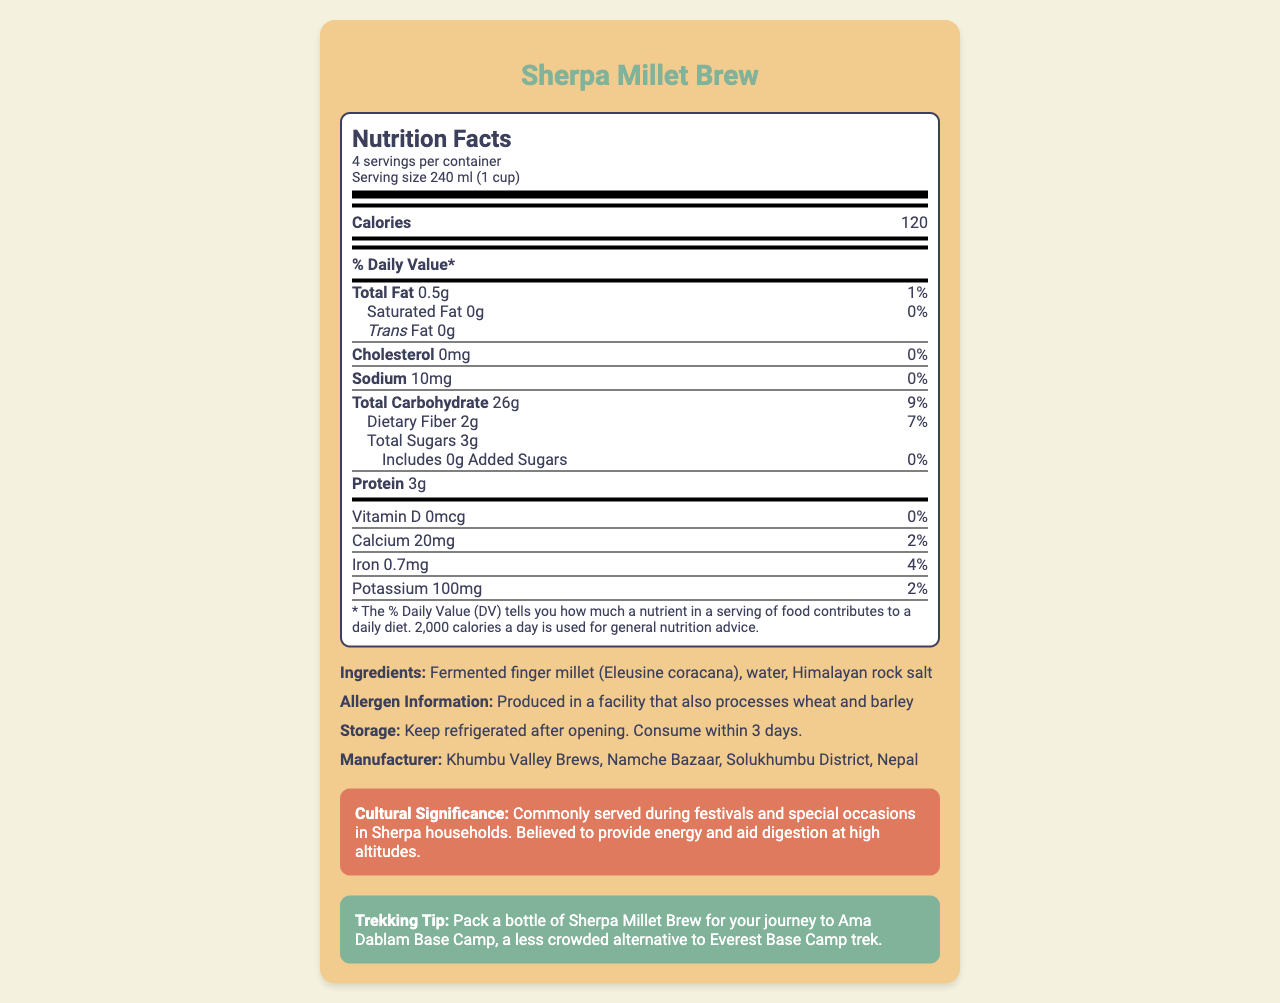what is the serving size of Sherpa Millet Brew? The serving size is explicitly mentioned in the document as "240 ml (1 cup)".
Answer: 240 ml (1 cup) how many calories are in one serving of Sherpa Millet Brew? The document states that there are 120 calories per serving.
Answer: 120 how much sodium does one serving of Sherpa Millet Brew contain? The Nutrition Facts section lists sodium content as 10 mg per serving.
Answer: 10 mg what is the daily value percentage of total fat in one serving? The document specifies that the daily value percentage for total fat in one serving is 1%.
Answer: 1% how many grams of protein are in one serving? The protein content for one serving is listed as 3 g in the document.
Answer: 3 g what are the ingredients of Sherpa Millet Brew? The ingredients are provided as "Fermented finger millet (Eleusine coracana), water, Himalayan rock salt."
Answer: Fermented finger millet (Eleusine coracana), water, Himalayan rock salt which nutrient has the highest daily value percentage per serving? The highest daily value percentage per serving is for total carbohydrate, which is 9%.
Answer: Total Carbohydrate what is the manufacturer location of Sherpa Millet Brew? A. Kathmandu B. Namche Bazaar C. Solukhumbu The manufacturer is listed as "Khumbu Valley Brews, Namche Bazaar, Solukhumbu District, Nepal."
Answer: B. Namche Bazaar how much dietary fiber is in one serving, and what is its daily value percentage? The document states that one serving contains 2 g of dietary fiber, which is 7% of the daily value.
Answer: 2 g, 7% according to the document, does Sherpa Millet Brew contain any added sugars? Yes/No The document explicitly mentions "Includes 0g Added Sugars."
Answer: No describe the cultural significance of Sherpa Millet Brew. The document states that it is commonly served during festivals and special occasions and is believed to provide energy and aid digestion at high altitudes.
Answer: Commonly served during festivals and special occasions in Sherpa households. Believed to provide energy and aid digestion at high altitudes. are any allergen-related precautions mentioned for Sherpa Millet Brew? The document mentions an allergen information section which states that it is produced in a facility that processes wheat and barley.
Answer: Yes, it is produced in a facility that also processes wheat and barley. what are the storage instructions for Sherpa Millet Brew? The storage instructions clearly state that it should be kept refrigerated after opening and consumed within 3 days.
Answer: Keep refrigerated after opening. Consume within 3 days. can the daily value percentage for vitamin D be determined from the document? The document shows that the daily value percentage for vitamin D is 0%.
Answer: 0% does the document provide any tips for trekkers? The document includes a trekking tip section with this suggestion.
Answer: Yes, it suggests packing a bottle of Sherpa Millet Brew for the journey to Ama Dablam Base Camp. how many servings are there per container? The document states that there are 4 servings per container.
Answer: 4 how many grams of saturated fat are in one serving of Sherpa Millet Brew? The document states that one serving contains 0 g of saturated fat.
Answer: 0 g which mineral has the highest amount per serving? A. Calcium B. Iron C. Potassium Potassium content is 100 mg per serving, higher than calcium (20 mg) and iron (0.7 mg).
Answer: C. Potassium how does Sherpa Millet Brew contribute to energy and digestion according to cultural significance? The cultural significance section mentions that the beverage is believed to provide energy and aid digestion at high altitudes.
Answer: It is believed to provide energy and aid digestion at high altitudes. what is the total fat content per serving? The total fat content per serving is listed as 0.5 g.
Answer: 0.5 g what are the health benefits of Sherpa Millet Brew? The document provides nutritional information but does not explicitly state the health benefits aside from mentioning energy and digestion in the cultural significance section.
Answer: Cannot be determined 